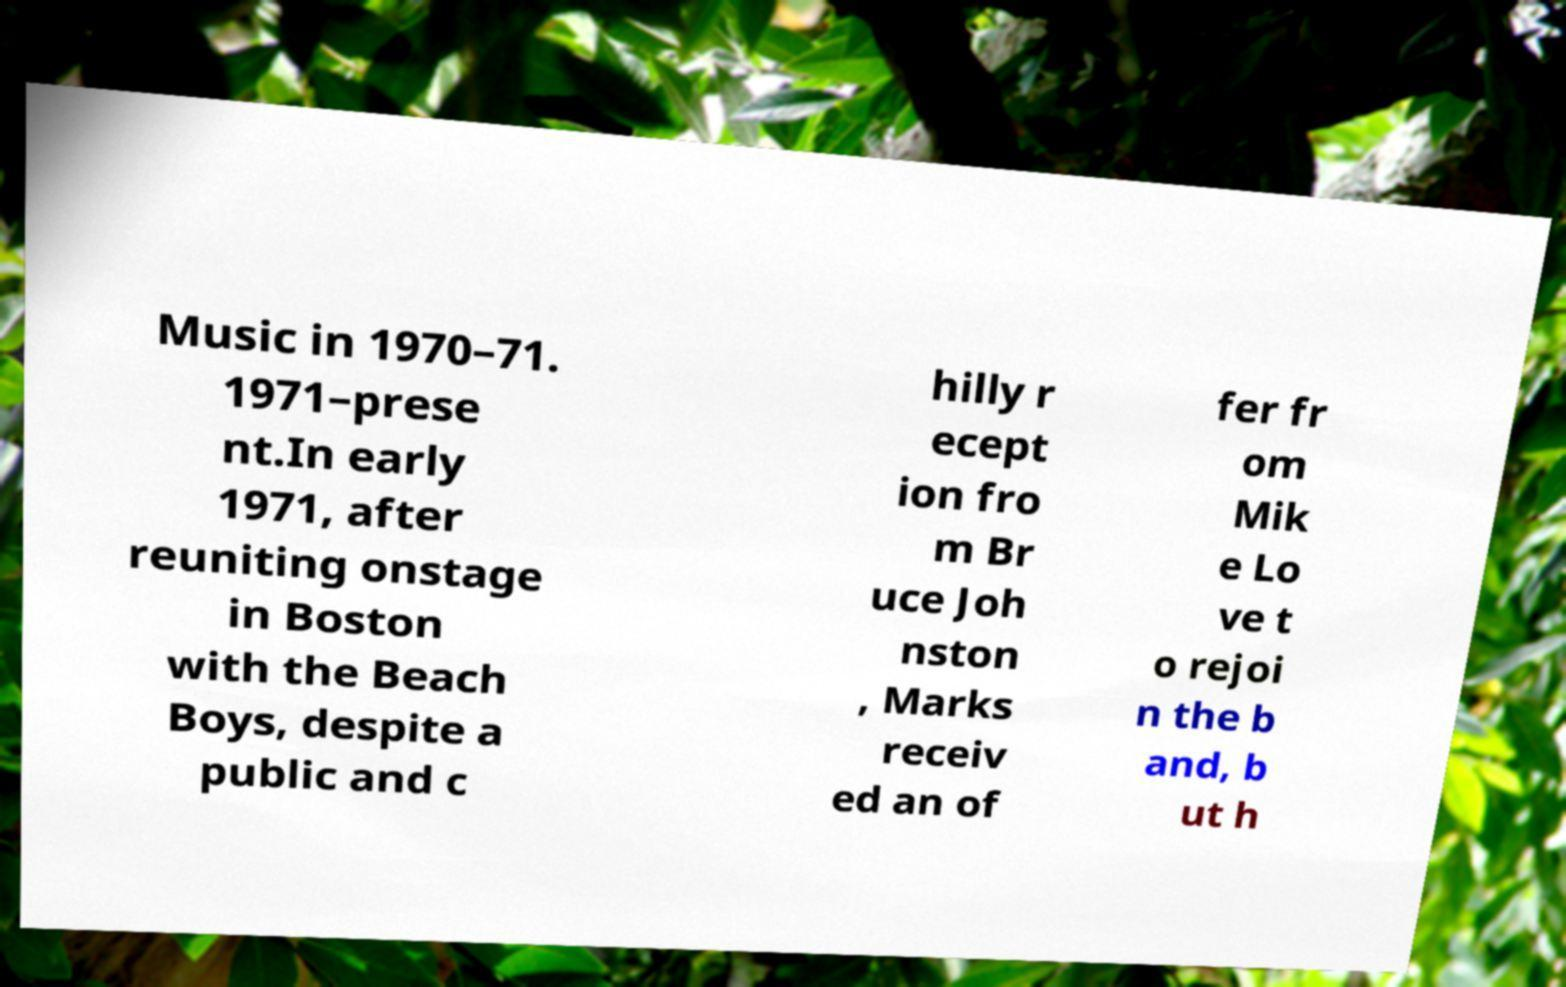Could you assist in decoding the text presented in this image and type it out clearly? Music in 1970–71. 1971–prese nt.In early 1971, after reuniting onstage in Boston with the Beach Boys, despite a public and c hilly r ecept ion fro m Br uce Joh nston , Marks receiv ed an of fer fr om Mik e Lo ve t o rejoi n the b and, b ut h 